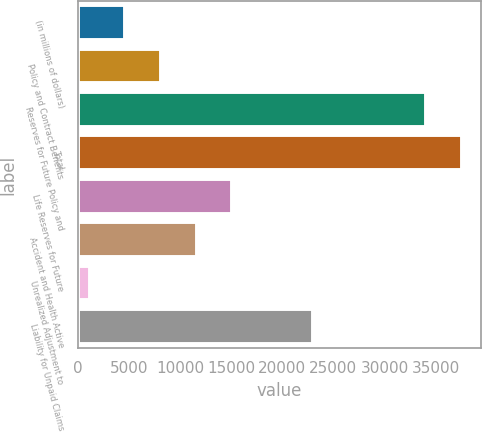Convert chart. <chart><loc_0><loc_0><loc_500><loc_500><bar_chart><fcel>(in millions of dollars)<fcel>Policy and Contract Benefits<fcel>Reserves for Future Policy and<fcel>Total<fcel>Life Reserves for Future<fcel>Accident and Health Active<fcel>Unrealized Adjustment to<fcel>Liability for Unpaid Claims<nl><fcel>4619.66<fcel>8118.02<fcel>34041.5<fcel>37539.9<fcel>15114.7<fcel>11616.4<fcel>1121.3<fcel>23047.7<nl></chart> 